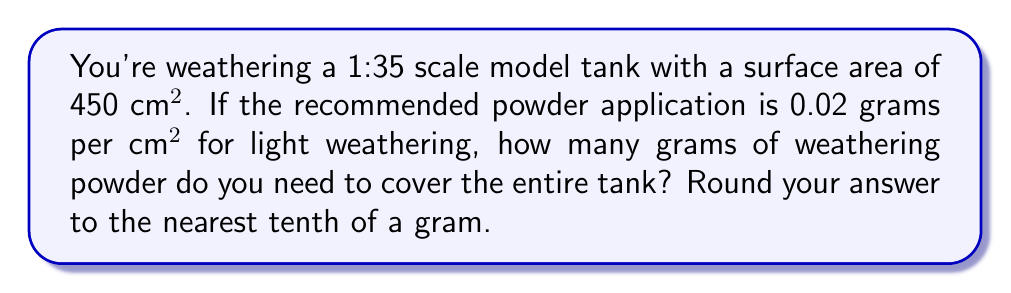Show me your answer to this math problem. To solve this problem, we'll follow these steps:

1) First, we need to identify the given information:
   - Surface area of the model tank: 450 cm²
   - Recommended powder application: 0.02 g/cm²

2) To find the total amount of powder needed, we'll multiply the surface area by the recommended application rate:

   $$ \text{Total powder} = \text{Surface area} \times \text{Application rate} $$

3) Let's substitute the values:

   $$ \text{Total powder} = 450 \text{ cm²} \times 0.02 \text{ g/cm²} $$

4) Now we can perform the multiplication:

   $$ \text{Total powder} = 9 \text{ g} $$

5) The question asks to round to the nearest tenth of a gram, but 9 g is already in that form.

Therefore, you need 9.0 grams of weathering powder to cover the entire tank with a light weathering effect.
Answer: 9.0 g 